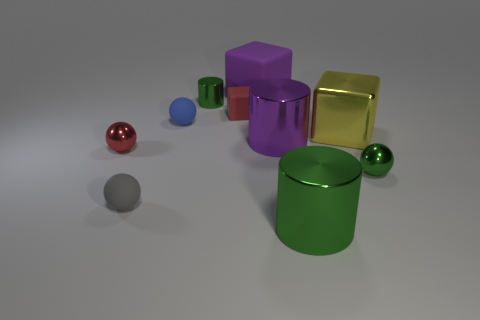Subtract all large green cylinders. How many cylinders are left? 2 Subtract all cubes. How many objects are left? 7 Subtract 3 cylinders. How many cylinders are left? 0 Add 1 large yellow cubes. How many large yellow cubes exist? 2 Subtract all red spheres. How many spheres are left? 3 Subtract 1 yellow cubes. How many objects are left? 9 Subtract all yellow spheres. Subtract all blue cylinders. How many spheres are left? 4 Subtract all brown cylinders. How many purple cubes are left? 1 Subtract all large purple rubber objects. Subtract all metal objects. How many objects are left? 3 Add 3 gray matte spheres. How many gray matte spheres are left? 4 